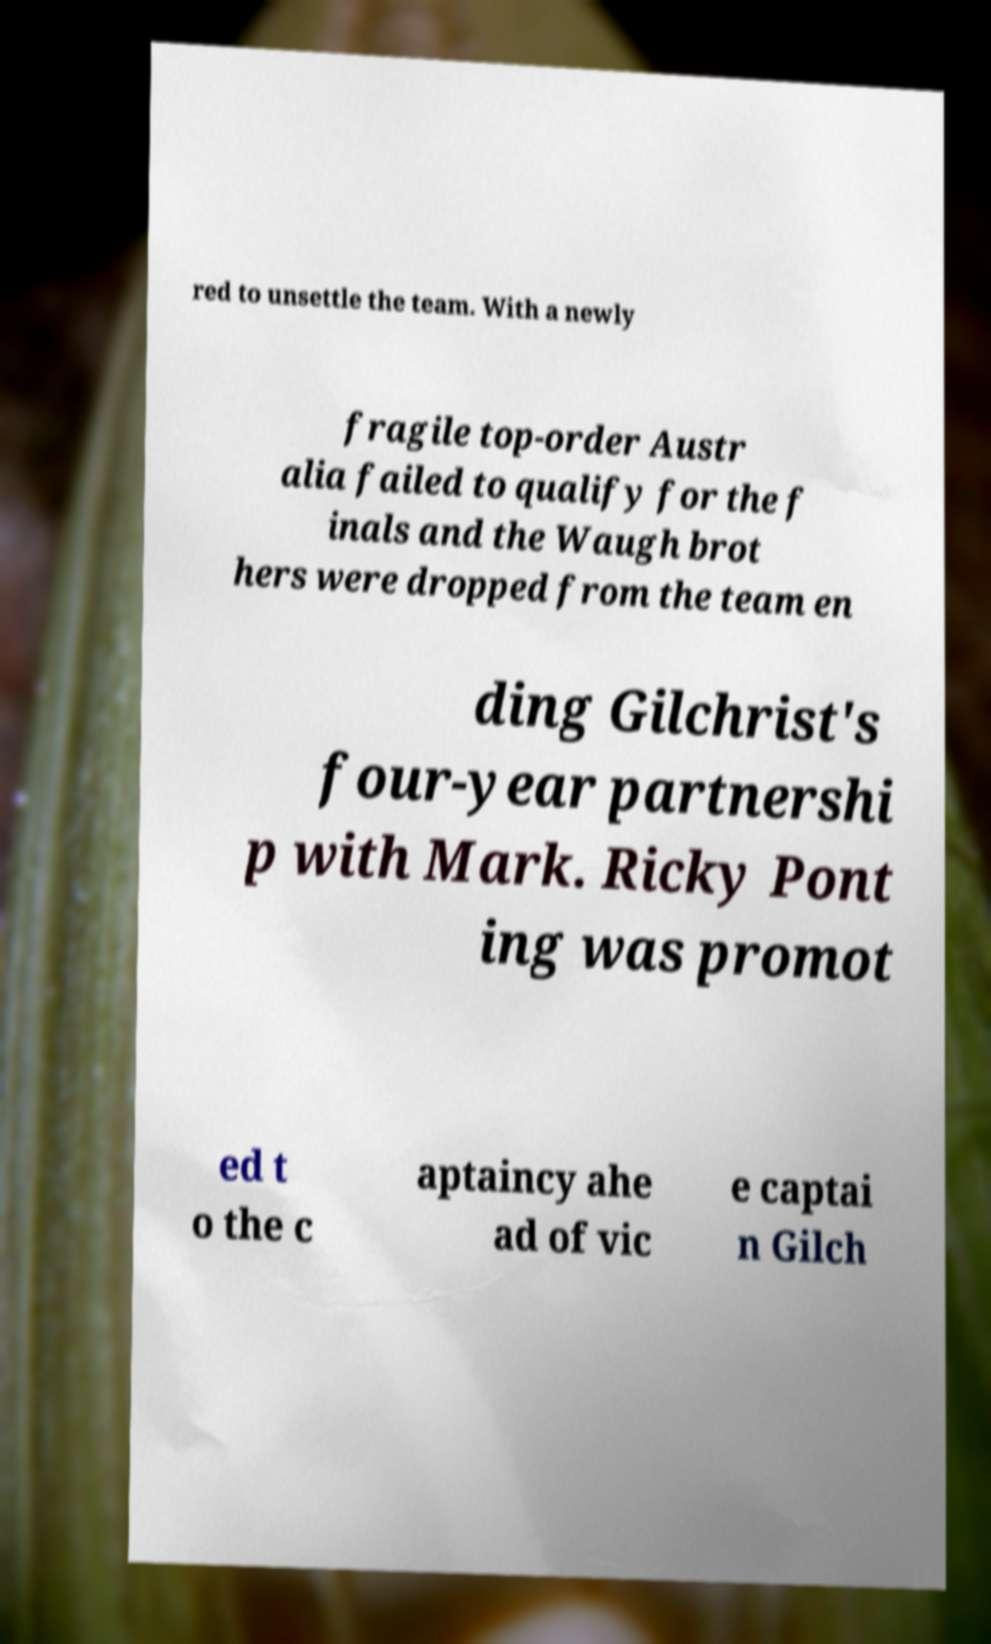Could you assist in decoding the text presented in this image and type it out clearly? red to unsettle the team. With a newly fragile top-order Austr alia failed to qualify for the f inals and the Waugh brot hers were dropped from the team en ding Gilchrist's four-year partnershi p with Mark. Ricky Pont ing was promot ed t o the c aptaincy ahe ad of vic e captai n Gilch 